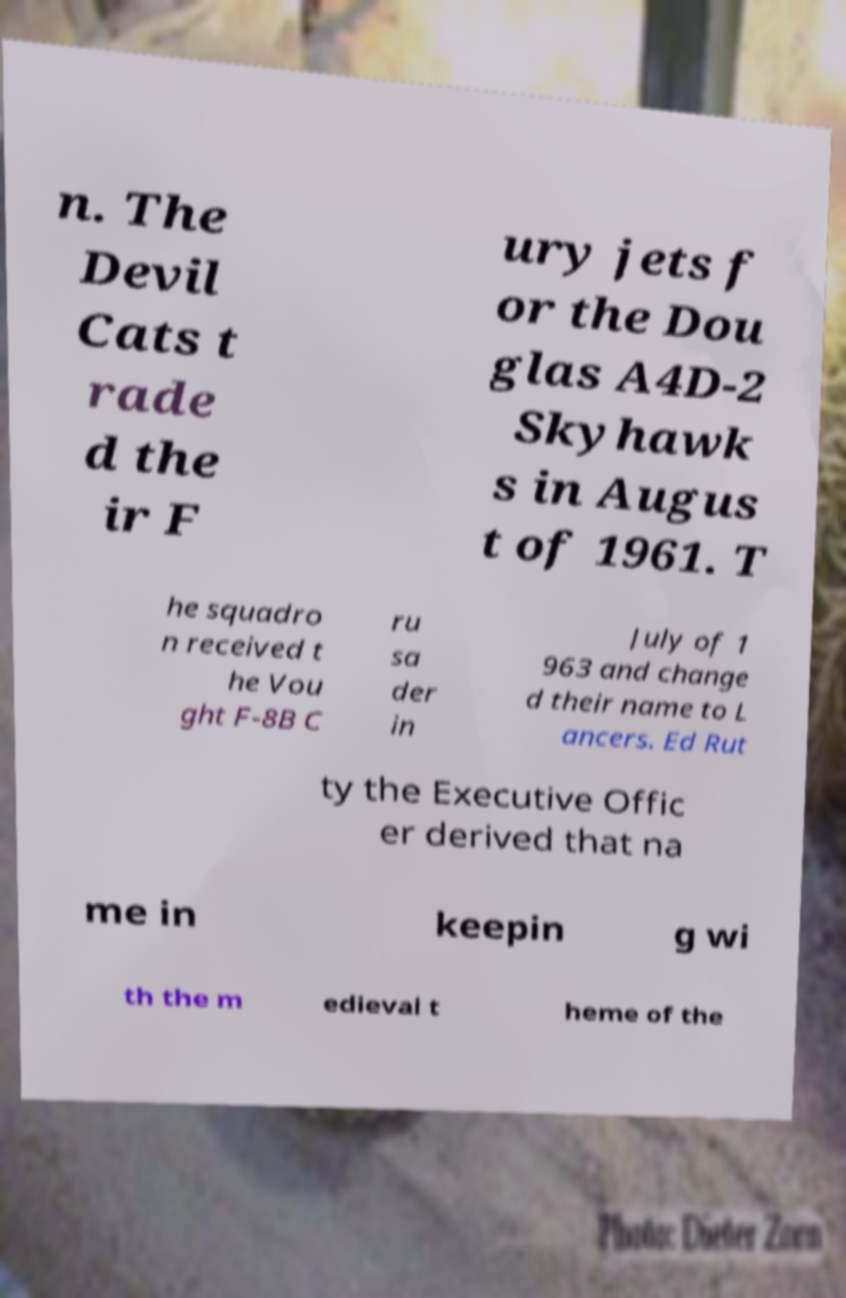Can you read and provide the text displayed in the image?This photo seems to have some interesting text. Can you extract and type it out for me? n. The Devil Cats t rade d the ir F ury jets f or the Dou glas A4D-2 Skyhawk s in Augus t of 1961. T he squadro n received t he Vou ght F-8B C ru sa der in July of 1 963 and change d their name to L ancers. Ed Rut ty the Executive Offic er derived that na me in keepin g wi th the m edieval t heme of the 